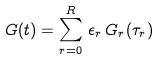<formula> <loc_0><loc_0><loc_500><loc_500>G ( t ) = \sum _ { r = 0 } ^ { R } \, \epsilon _ { r } \, G _ { r } ( \tau _ { r } )</formula> 